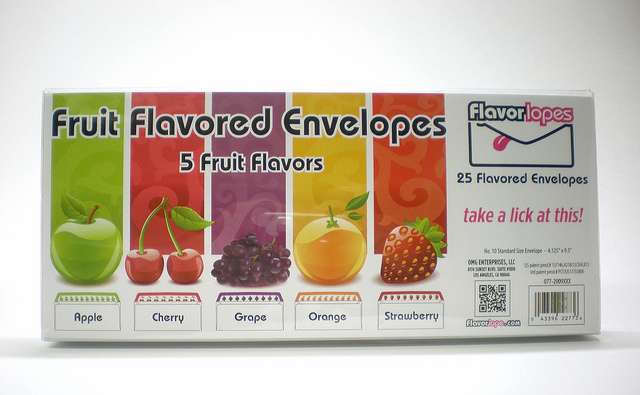Read and extract the text from this image. Fruit Flavored Envelopes flavors Fruit 5 Flavorlopes Envelpoes Flavored 25 this at lick a take Strawberry Orange Grope Cherry Apple 